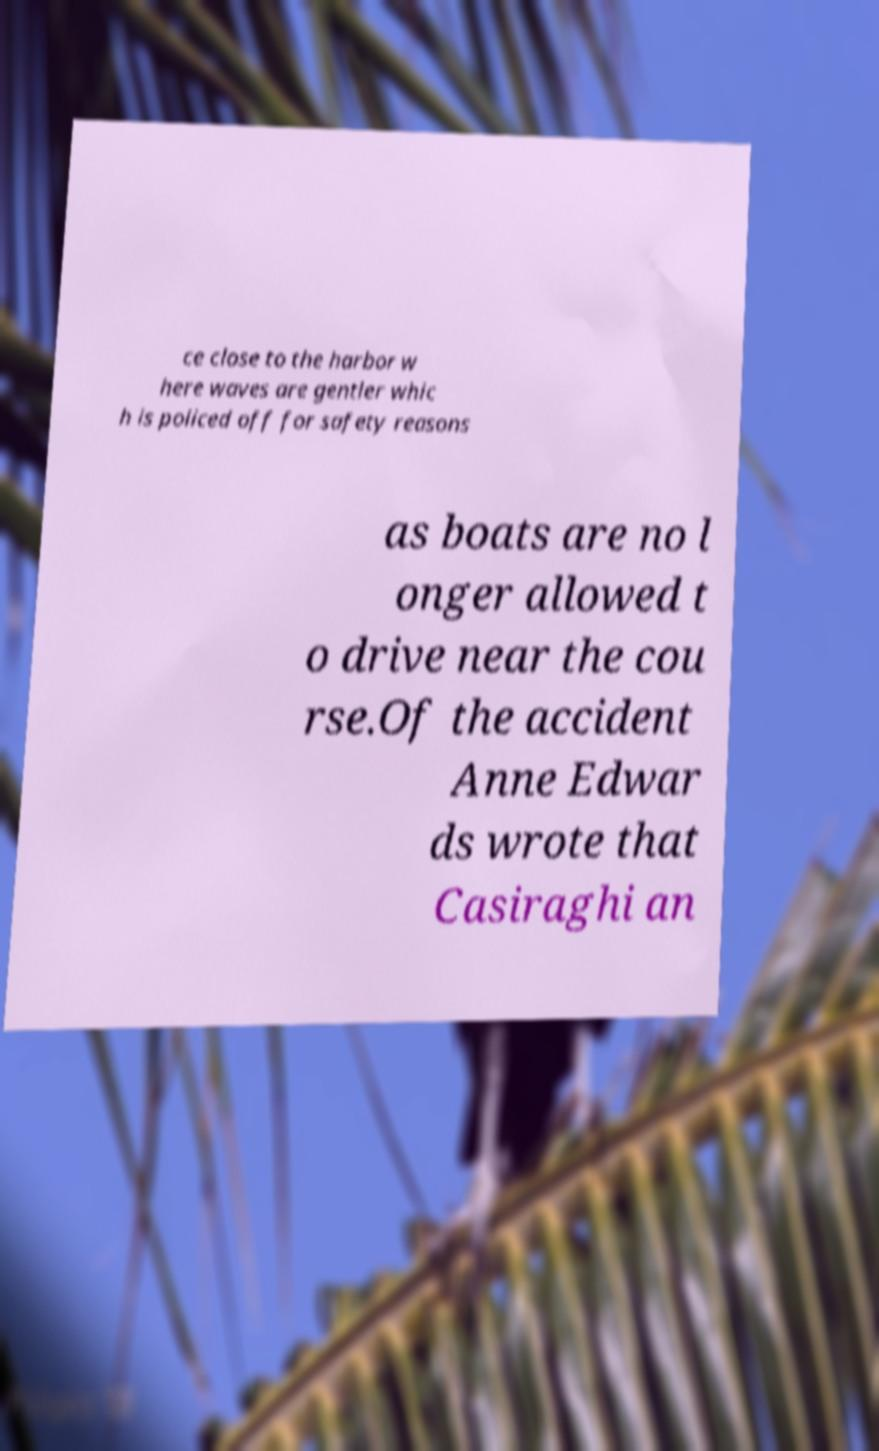Could you assist in decoding the text presented in this image and type it out clearly? ce close to the harbor w here waves are gentler whic h is policed off for safety reasons as boats are no l onger allowed t o drive near the cou rse.Of the accident Anne Edwar ds wrote that Casiraghi an 